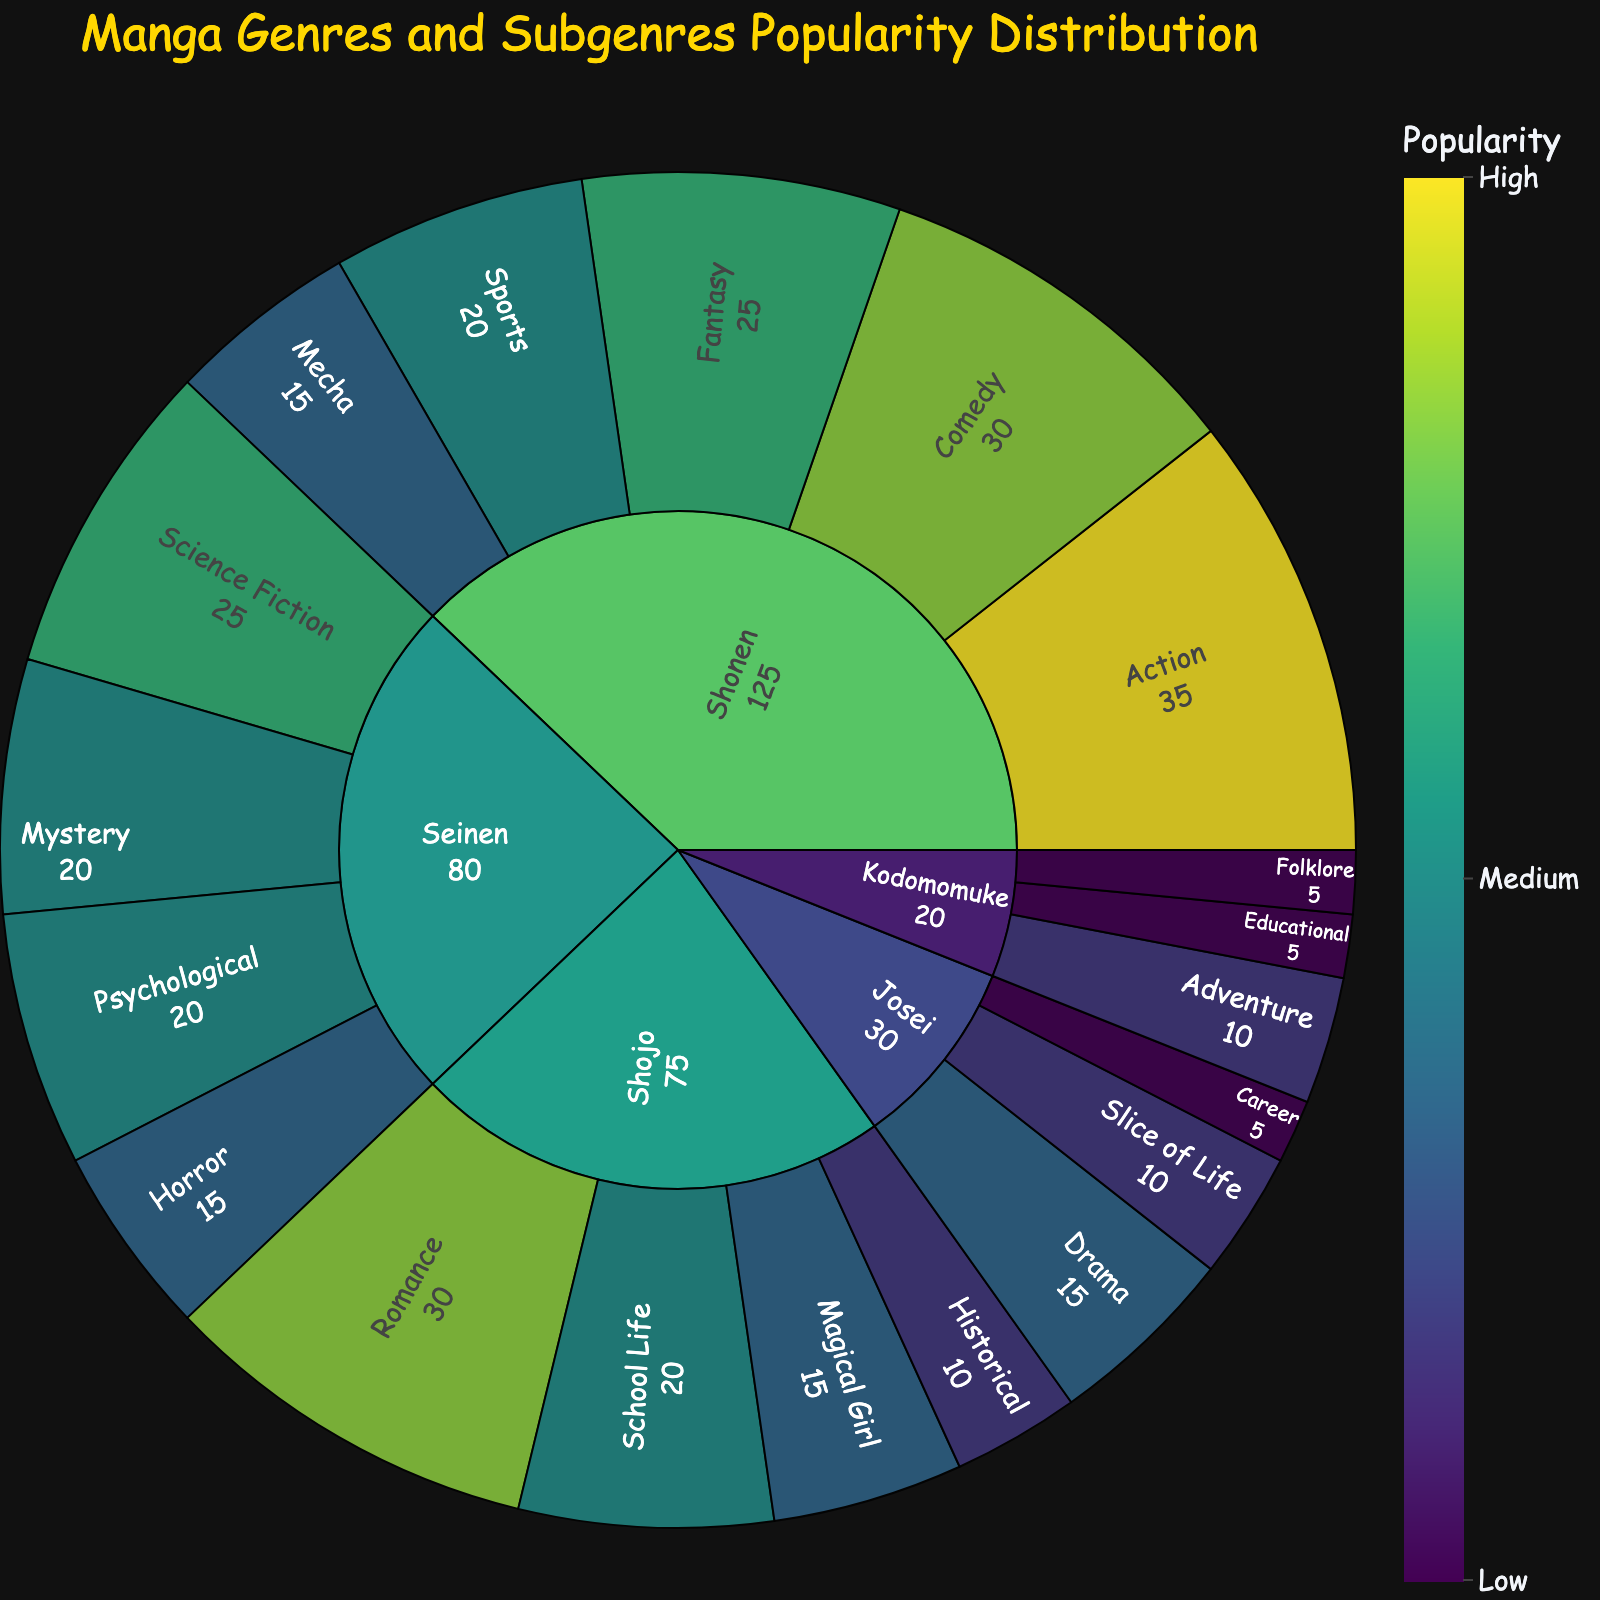Which manga genre has the highest total popularity? Look at the sunburst plot and sum the popularity of all subgenres under each main genre. The genre with the highest accumulated value will be the answer.
Answer: Shonen What is the least popular subgenre within the Shojo genre? Locate the Shojo genre within the plot and compare the popularity values of its subgenres. Identify the subgenre with the smallest popularity value.
Answer: Magical Girl How many subgenres are present within the Seinen genre? Count the number of branches stemming from the Seinen genre in the sunburst plot.
Answer: 4 Which genre has more popularity, Seinen or Shojo? Sum the popularity values of all subgenres within Seinen and compare it to the sum of Shojo's subgenres. The one with the higher total value is the answer.
Answer: Seinen What’s the total popularity of subgenres under Josei and Kodomomuke combined? Add up the popularity values of the subgenres under Josei and then do the same for Kodomomuke. Sum these two totals together. Josei: 10 + 15 + 5 = 30, Kodomomuke: 5 + 10 + 5 = 20, Total: 30 + 20 = 50
Answer: 50 Between the subgenres 'Action' in Shonen and 'Science Fiction' in Seinen, which is more popular? Identify the popularity values of 'Action' under Shonen and 'Science Fiction' under Seinen. Compare the two values to determine which is higher. Action: 35, Science Fiction: 25
Answer: Action Which subgenre has a higher popularity, 'Romance' in Shojo or 'Slice of Life' in Josei? Locate the popularity values of 'Romance' under Shojo and 'Slice of Life' under Josei in the plot. Compare the two values to find which is larger. Romance: 30, Slice of Life: 10
Answer: Romance What is the combined popularity of the 'Fantasy' and 'Mecha' subgenres within Shonen? Find the popularity values of 'Fantasy' and 'Mecha', both under Shonen. Sum these values together. Fantasy: 25, Mecha: 15, Combined: 25 + 15 = 40
Answer: 40 What is the total number of genres depicted in the plot? Identify and count the distinct overarching genres listed in the plot.
Answer: 5 